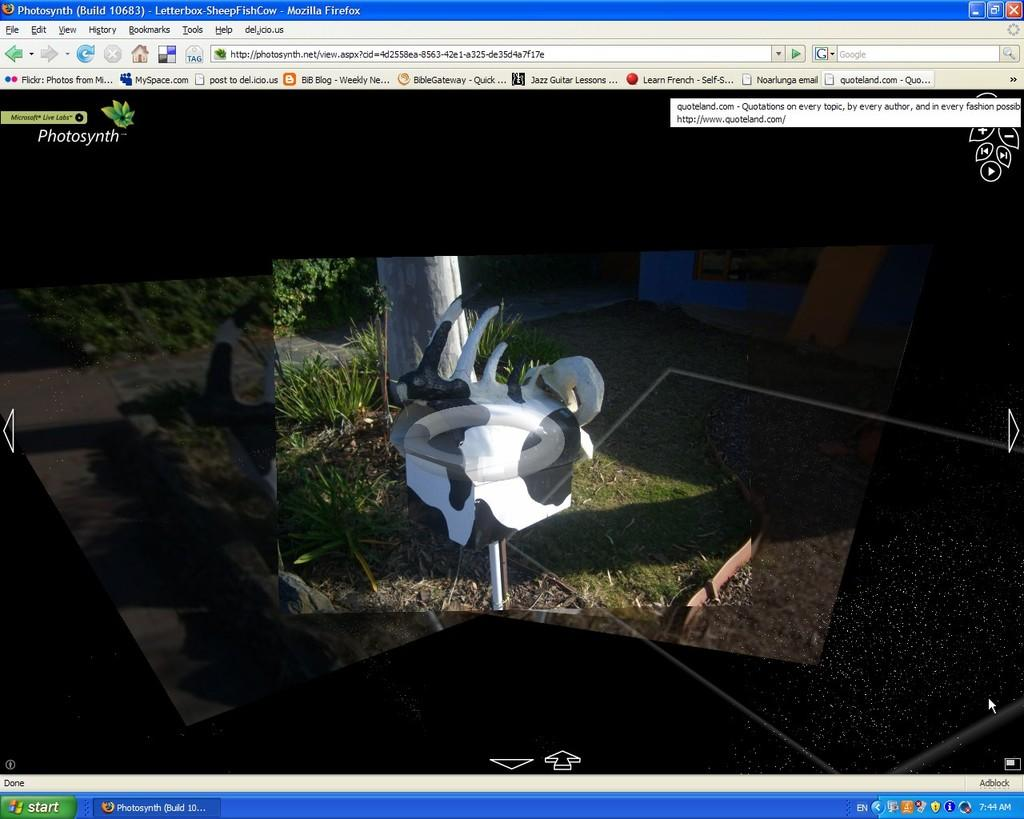What type of image is being described? The image is a screenshot of a web page. What type of wine is being advertised on the web page in the image? There is no wine or advertisement present in the image, as it is a screenshot of a web page without any specific content mentioned. 